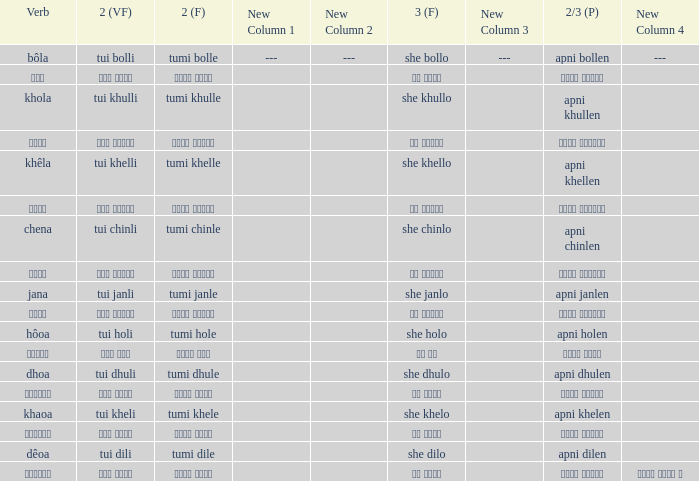What is the verb for Khola? She khullo. 